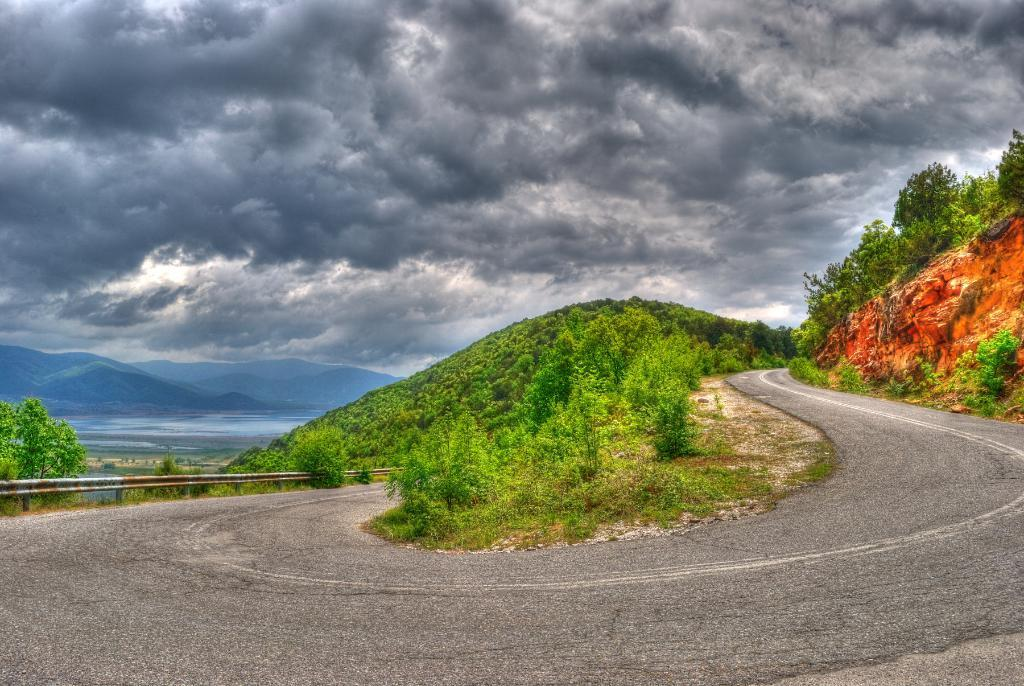What type of road feature is depicted in the image? There is a steep curve of a road in the image. What safety feature is present along the road? There is a barrier along the road. What type of vegetation is present beside the road? There are small plants beside the road. What can be seen in the background of the image? There are hills and a water body in the background of the image. How would you describe the sky in the image? The sky is clouded in the image. Where is the kettle placed in the image? There is no kettle present in the image. What type of mountain is visible in the background of the image? There are hills visible in the background of the image, but no specific mountain can be identified. 